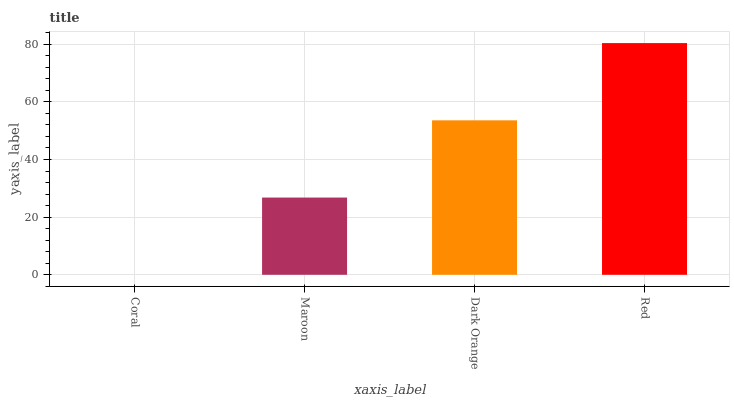Is Coral the minimum?
Answer yes or no. Yes. Is Red the maximum?
Answer yes or no. Yes. Is Maroon the minimum?
Answer yes or no. No. Is Maroon the maximum?
Answer yes or no. No. Is Maroon greater than Coral?
Answer yes or no. Yes. Is Coral less than Maroon?
Answer yes or no. Yes. Is Coral greater than Maroon?
Answer yes or no. No. Is Maroon less than Coral?
Answer yes or no. No. Is Dark Orange the high median?
Answer yes or no. Yes. Is Maroon the low median?
Answer yes or no. Yes. Is Red the high median?
Answer yes or no. No. Is Red the low median?
Answer yes or no. No. 